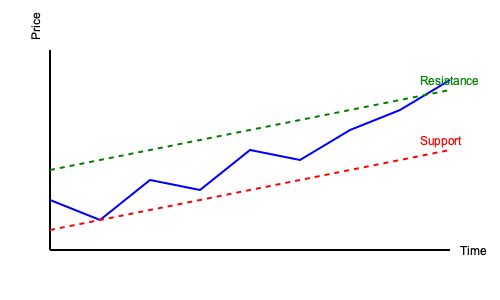Based on the stock price chart for McDonald's, which technical analysis pattern is most likely forming, and what does it suggest about the future stock price movement? To analyze the chart and identify the pattern:

1. Observe the overall trend: The blue line representing the stock price shows an upward trajectory over time.

2. Identify key elements:
   a. The red dashed line represents a rising support level.
   b. The green dashed line represents a rising resistance level.
   c. The stock price is moving between these two converging trend lines.

3. Recognize the pattern: This formation is known as an ascending triangle pattern.

4. Understand the implications:
   a. Ascending triangles are generally considered bullish patterns.
   b. The rising support line indicates increasing demand for the stock.
   c. The flat resistance line suggests a fixed price level where sellers become active.

5. Predict the potential outcome:
   a. In most cases, the price is expected to break out above the resistance level.
   b. The breakout typically occurs when 2/3 to 3/4 of the triangle pattern is complete.
   c. If a breakout occurs, the price target is often calculated by measuring the height of the triangle at its widest point and projecting that distance from the breakout point.

6. Consider the skeptical persona:
   Despite the generally bullish interpretation of this pattern, a skeptical investor should be cautious and consider other factors such as fundamental analysis, market conditions, and potential risks before making investment decisions.
Answer: Ascending triangle; suggests potential bullish breakout 